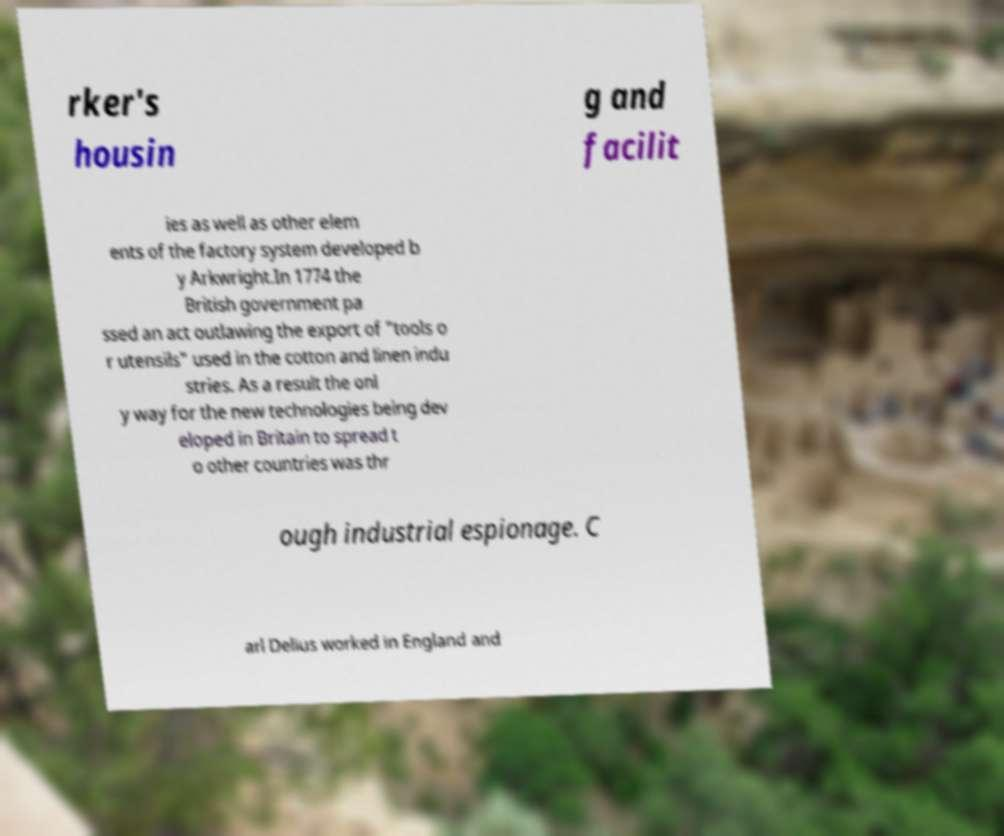What messages or text are displayed in this image? I need them in a readable, typed format. rker's housin g and facilit ies as well as other elem ents of the factory system developed b y Arkwright.In 1774 the British government pa ssed an act outlawing the export of "tools o r utensils" used in the cotton and linen indu stries. As a result the onl y way for the new technologies being dev eloped in Britain to spread t o other countries was thr ough industrial espionage. C arl Delius worked in England and 